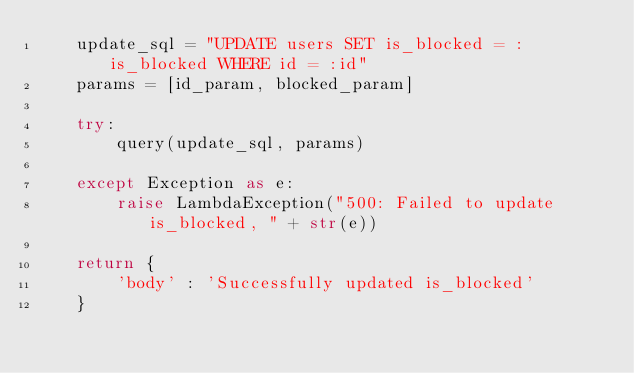Convert code to text. <code><loc_0><loc_0><loc_500><loc_500><_Python_>    update_sql = "UPDATE users SET is_blocked = :is_blocked WHERE id = :id"
    params = [id_param, blocked_param]
    
    try:
        query(update_sql, params)
        
    except Exception as e:
        raise LambdaException("500: Failed to update is_blocked, " + str(e))
        
    return {
        'body' : 'Successfully updated is_blocked'
    }</code> 